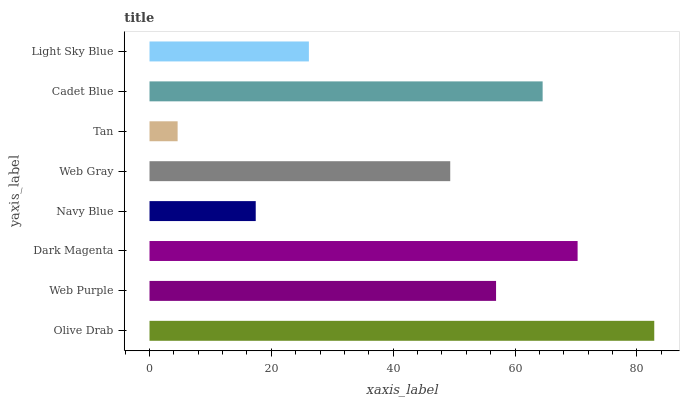Is Tan the minimum?
Answer yes or no. Yes. Is Olive Drab the maximum?
Answer yes or no. Yes. Is Web Purple the minimum?
Answer yes or no. No. Is Web Purple the maximum?
Answer yes or no. No. Is Olive Drab greater than Web Purple?
Answer yes or no. Yes. Is Web Purple less than Olive Drab?
Answer yes or no. Yes. Is Web Purple greater than Olive Drab?
Answer yes or no. No. Is Olive Drab less than Web Purple?
Answer yes or no. No. Is Web Purple the high median?
Answer yes or no. Yes. Is Web Gray the low median?
Answer yes or no. Yes. Is Tan the high median?
Answer yes or no. No. Is Light Sky Blue the low median?
Answer yes or no. No. 